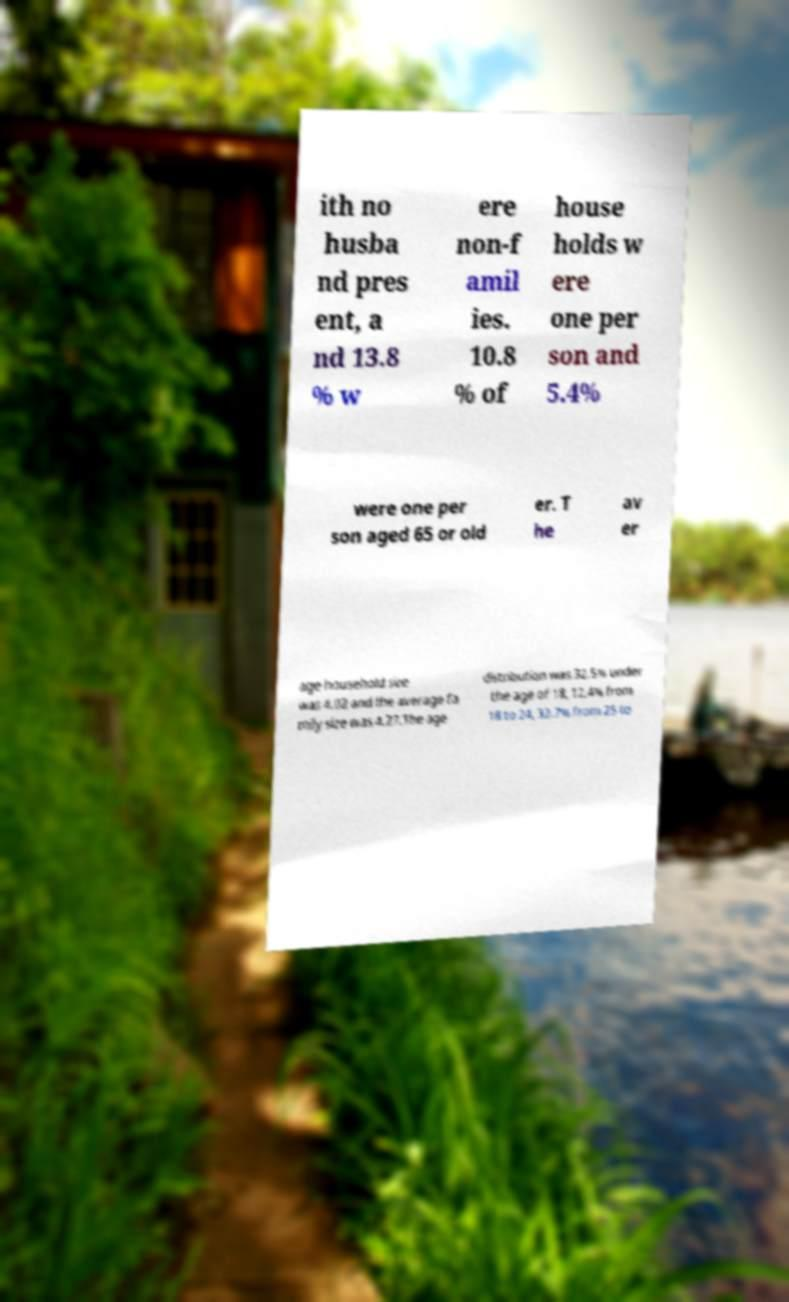For documentation purposes, I need the text within this image transcribed. Could you provide that? ith no husba nd pres ent, a nd 13.8 % w ere non-f amil ies. 10.8 % of house holds w ere one per son and 5.4% were one per son aged 65 or old er. T he av er age household size was 4.02 and the average fa mily size was 4.27.The age distribution was 32.5% under the age of 18, 12.4% from 18 to 24, 32.7% from 25 to 